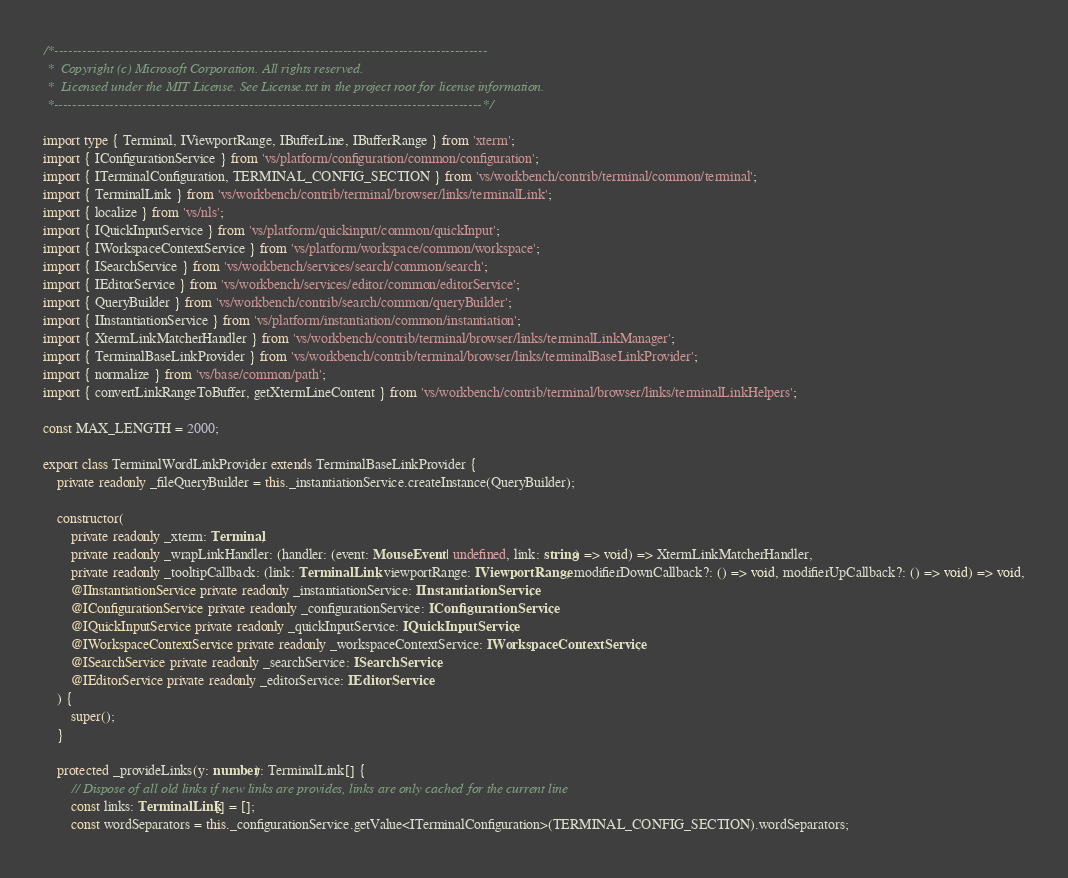Convert code to text. <code><loc_0><loc_0><loc_500><loc_500><_TypeScript_>/*---------------------------------------------------------------------------------------------
 *  Copyright (c) Microsoft Corporation. All rights reserved.
 *  Licensed under the MIT License. See License.txt in the project root for license information.
 *--------------------------------------------------------------------------------------------*/

import type { Terminal, IViewportRange, IBufferLine, IBufferRange } from 'xterm';
import { IConfigurationService } from 'vs/platform/configuration/common/configuration';
import { ITerminalConfiguration, TERMINAL_CONFIG_SECTION } from 'vs/workbench/contrib/terminal/common/terminal';
import { TerminalLink } from 'vs/workbench/contrib/terminal/browser/links/terminalLink';
import { localize } from 'vs/nls';
import { IQuickInputService } from 'vs/platform/quickinput/common/quickInput';
import { IWorkspaceContextService } from 'vs/platform/workspace/common/workspace';
import { ISearchService } from 'vs/workbench/services/search/common/search';
import { IEditorService } from 'vs/workbench/services/editor/common/editorService';
import { QueryBuilder } from 'vs/workbench/contrib/search/common/queryBuilder';
import { IInstantiationService } from 'vs/platform/instantiation/common/instantiation';
import { XtermLinkMatcherHandler } from 'vs/workbench/contrib/terminal/browser/links/terminalLinkManager';
import { TerminalBaseLinkProvider } from 'vs/workbench/contrib/terminal/browser/links/terminalBaseLinkProvider';
import { normalize } from 'vs/base/common/path';
import { convertLinkRangeToBuffer, getXtermLineContent } from 'vs/workbench/contrib/terminal/browser/links/terminalLinkHelpers';

const MAX_LENGTH = 2000;

export class TerminalWordLinkProvider extends TerminalBaseLinkProvider {
	private readonly _fileQueryBuilder = this._instantiationService.createInstance(QueryBuilder);

	constructor(
		private readonly _xterm: Terminal,
		private readonly _wrapLinkHandler: (handler: (event: MouseEvent | undefined, link: string) => void) => XtermLinkMatcherHandler,
		private readonly _tooltipCallback: (link: TerminalLink, viewportRange: IViewportRange, modifierDownCallback?: () => void, modifierUpCallback?: () => void) => void,
		@IInstantiationService private readonly _instantiationService: IInstantiationService,
		@IConfigurationService private readonly _configurationService: IConfigurationService,
		@IQuickInputService private readonly _quickInputService: IQuickInputService,
		@IWorkspaceContextService private readonly _workspaceContextService: IWorkspaceContextService,
		@ISearchService private readonly _searchService: ISearchService,
		@IEditorService private readonly _editorService: IEditorService
	) {
		super();
	}

	protected _provideLinks(y: number): TerminalLink[] {
		// Dispose of all old links if new links are provides, links are only cached for the current line
		const links: TerminalLink[] = [];
		const wordSeparators = this._configurationService.getValue<ITerminalConfiguration>(TERMINAL_CONFIG_SECTION).wordSeparators;</code> 